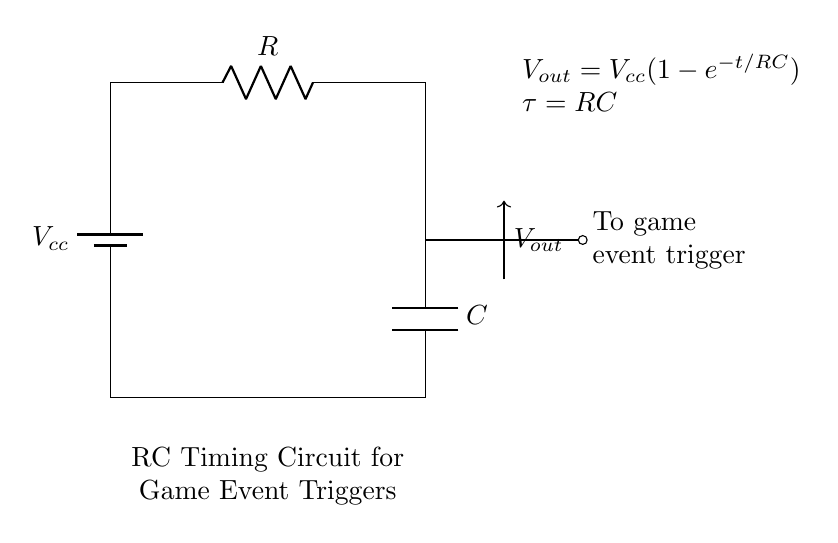What is the power supply voltage in this circuit? The circuit is powered by a DC battery, denoted by \( V_{cc} \), which is the voltage input to the circuit. The value of the battery is typically specified in the parameters of the circuit.
Answer: Vcc What components are present in the circuit? The circuit includes a battery, a resistor labeled \( R \), and a capacitor labeled \( C \). These components are standard in an RC timing circuit and are connected in a specific configuration.
Answer: Battery, Resistor, Capacitor What does \( V_{out} \) represent in this circuit? \( V_{out} \) is the voltage across the capacitor, which influences the game's event trigger. It represents the potential difference being output at that point in the circuit.
Answer: Output voltage What is the time constant \( \tau \) in this circuit? The time constant \( \tau \) for an RC circuit is calculated as the product of the resistance and the capacitance, represented by \( \tau = RC \). This parameter determines how quickly the capacitor charges through the resistor.
Answer: RC How does \( V_{out} \) change over time after the circuit is powered? The expression \( V_{out} = V_{cc}(1-e^{-t/RC}) \) indicates that \( V_{out} \) starts at zero and asymptotically approaches \( V_{cc} \) as time increases. Initially, it rises rapidly and slows down as it nears \( V_{cc} \).
Answer: Increases to Vcc If the resistance \( R \) increases, what happens to the time constant? An increase in \( R \) directly results in a larger time constant \( \tau \) since \( \tau = RC \). As resistance increases, the time taken for the capacitor to charge also increases, affecting the timing of game event triggers.
Answer: Increases 